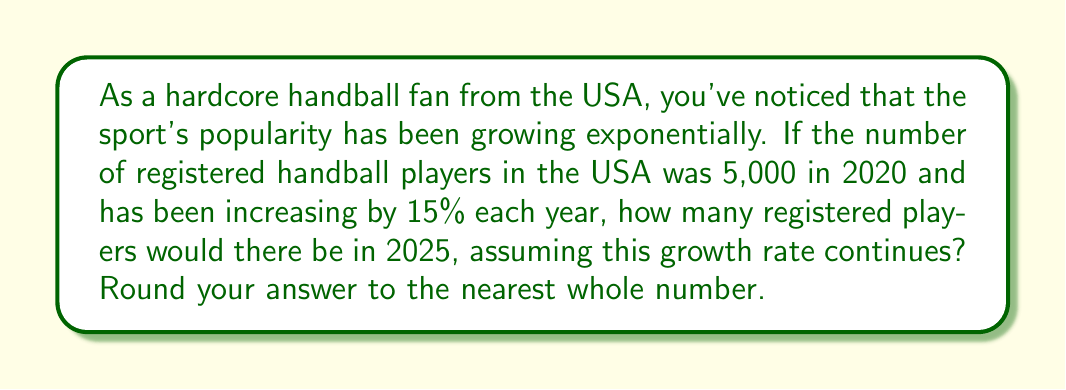Show me your answer to this math problem. Let's approach this step-by-step using the exponential growth formula:

$$A = P(1 + r)^t$$

Where:
$A$ = final amount
$P$ = initial amount (principal)
$r$ = annual growth rate (as a decimal)
$t$ = time in years

Given:
$P = 5,000$ (initial number of players in 2020)
$r = 0.15$ (15% growth rate)
$t = 5$ (years from 2020 to 2025)

Let's plug these values into our formula:

$$A = 5,000(1 + 0.15)^5$$

Now, let's calculate:

$$\begin{align}
A &= 5,000(1.15)^5 \\
&= 5,000(2.0113689) \\
&= 10,056.8445
\end{align}$$

Rounding to the nearest whole number:

$$A \approx 10,057$$
Answer: 10,057 registered handball players 